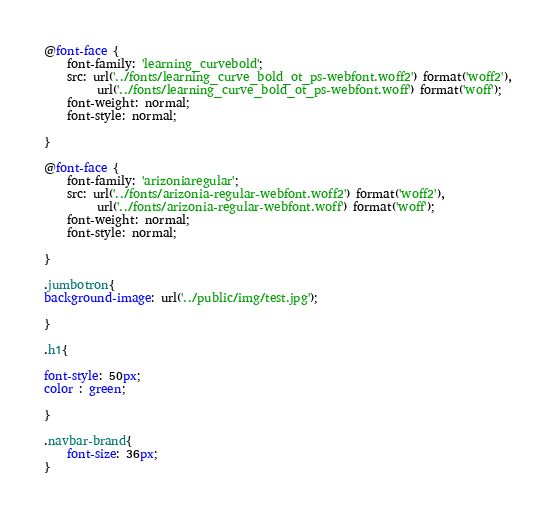<code> <loc_0><loc_0><loc_500><loc_500><_CSS_>@font-face {
    font-family: 'learning_curvebold';
    src: url('../fonts/learning_curve_bold_ot_ps-webfont.woff2') format('woff2'),
         url('../fonts/learning_curve_bold_ot_ps-webfont.woff') format('woff');
    font-weight: normal;
    font-style: normal;

}

@font-face {
    font-family: 'arizoniaregular';
    src: url('../fonts/arizonia-regular-webfont.woff2') format('woff2'),
         url('../fonts/arizonia-regular-webfont.woff') format('woff');
    font-weight: normal;
    font-style: normal;

}

.jumbotron{
background-image: url('../public/img/test.jpg');    

}

.h1{
    
font-style: 50px;
color : green; 
    
}

.navbar-brand{
    font-size: 36px;
}

</code> 